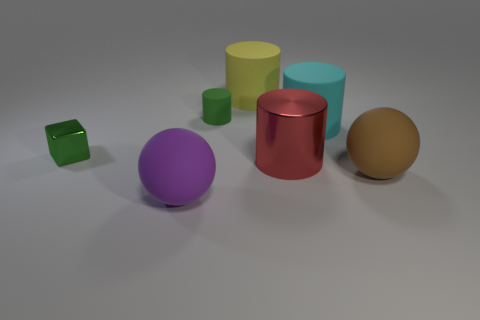What color is the big rubber object that is to the left of the brown rubber thing and in front of the tiny green shiny thing?
Give a very brief answer. Purple. Does the red thing have the same shape as the large yellow object?
Offer a very short reply. Yes. What is the size of the shiny object that is the same color as the small cylinder?
Ensure brevity in your answer.  Small. What is the shape of the big matte thing that is behind the green object that is to the right of the green cube?
Your answer should be compact. Cylinder. Do the brown thing and the large purple matte thing that is in front of the red thing have the same shape?
Make the answer very short. Yes. What is the color of the other rubber ball that is the same size as the brown sphere?
Offer a very short reply. Purple. Is the number of purple rubber things that are right of the green cylinder less than the number of brown rubber objects on the left side of the purple rubber thing?
Your answer should be very brief. No. What shape is the thing that is left of the thing in front of the big ball to the right of the purple matte thing?
Your answer should be compact. Cube. There is a shiny object behind the big red metallic cylinder; is it the same color as the ball that is on the right side of the big purple matte thing?
Keep it short and to the point. No. What shape is the metal object that is the same color as the small cylinder?
Offer a very short reply. Cube. 